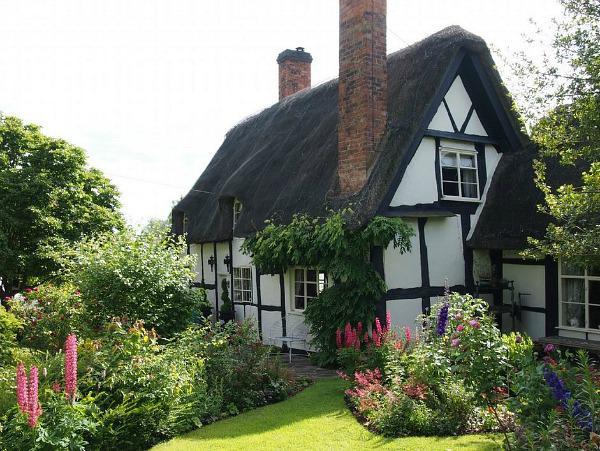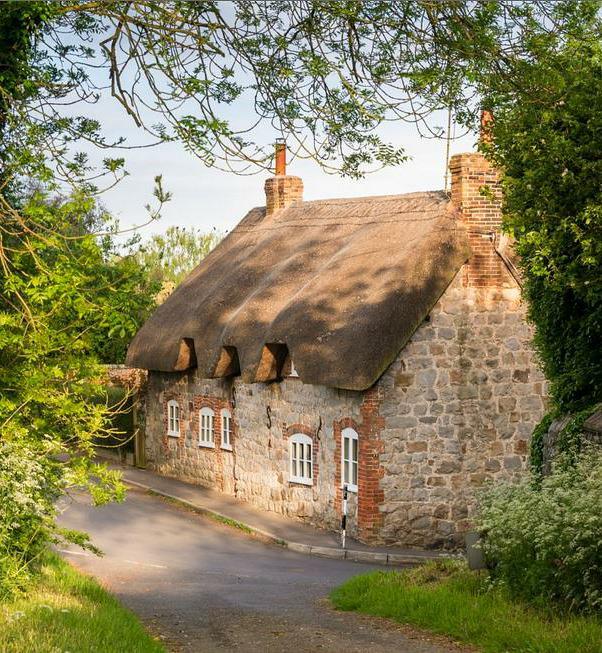The first image is the image on the left, the second image is the image on the right. Evaluate the accuracy of this statement regarding the images: "There are fewer than five chimneys.". Is it true? Answer yes or no. Yes. The first image is the image on the left, the second image is the image on the right. For the images shown, is this caption "A fence is put up around the house on the right." true? Answer yes or no. No. 